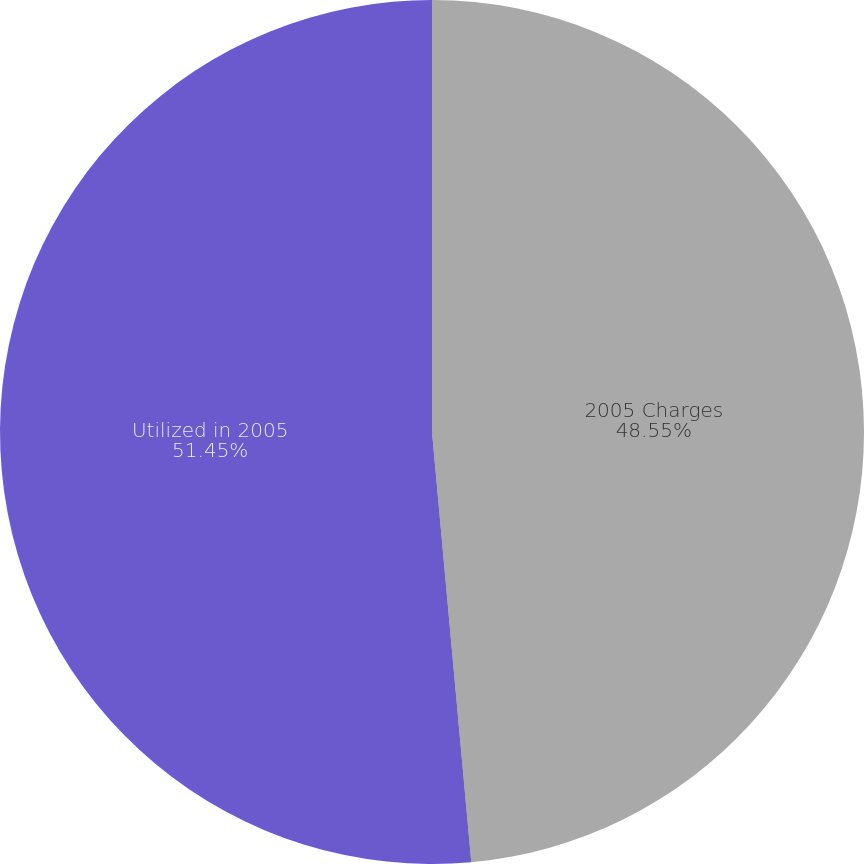Convert chart to OTSL. <chart><loc_0><loc_0><loc_500><loc_500><pie_chart><fcel>2005 Charges<fcel>Utilized in 2005<nl><fcel>48.55%<fcel>51.45%<nl></chart> 